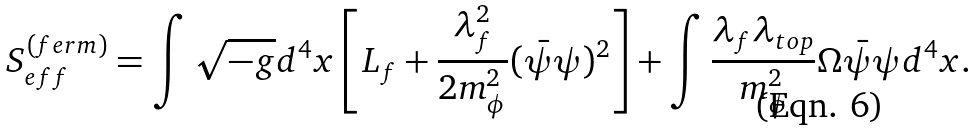Convert formula to latex. <formula><loc_0><loc_0><loc_500><loc_500>S ^ { ( f e r m ) } _ { e f f } = \int \sqrt { - g } d ^ { 4 } x \left [ L _ { f } + \frac { \lambda _ { f } ^ { 2 } } { 2 m _ { \phi } ^ { 2 } } ( \bar { \psi } \psi ) ^ { 2 } \right ] + \int \frac { \lambda _ { f } \lambda _ { t o p } } { m _ { \phi } ^ { 2 } } \Omega \bar { \psi } \psi d ^ { 4 } x .</formula> 